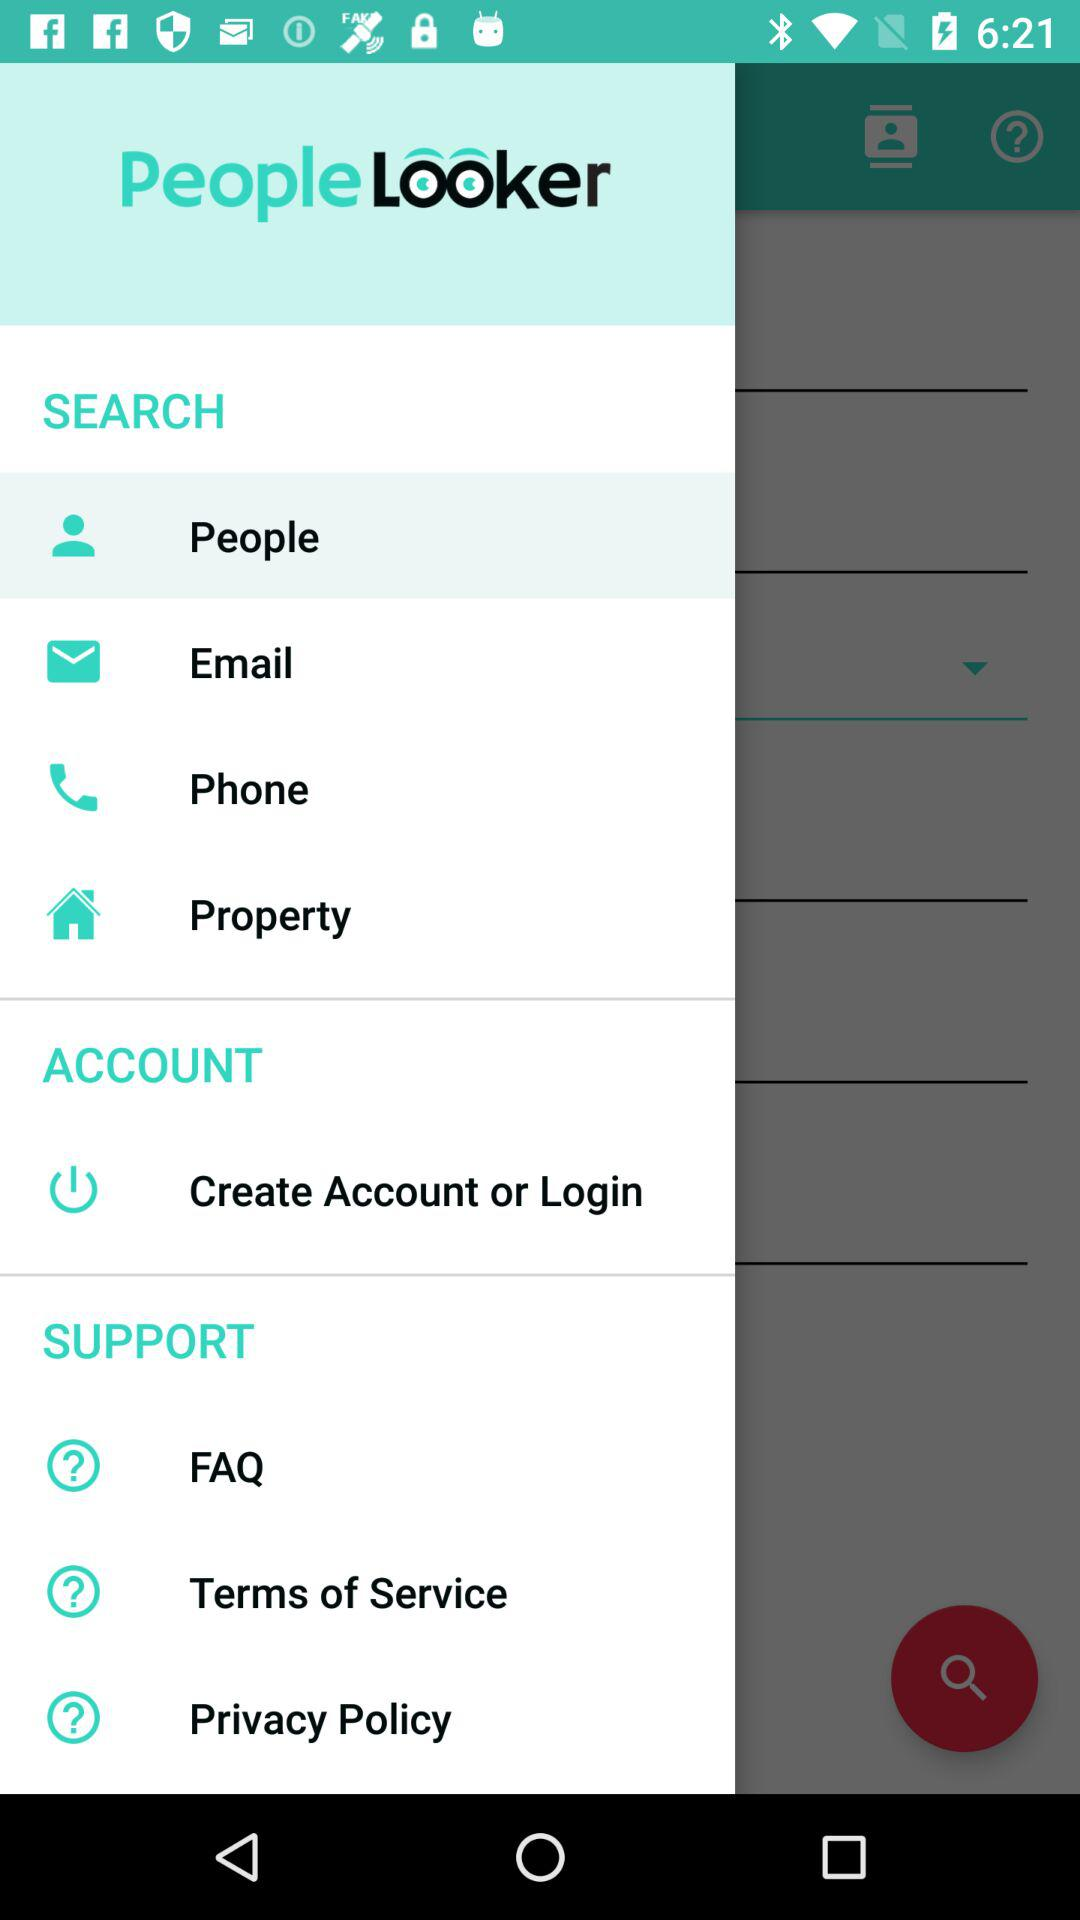What is the name of the application? The name of the application is "PeopleLooker". 